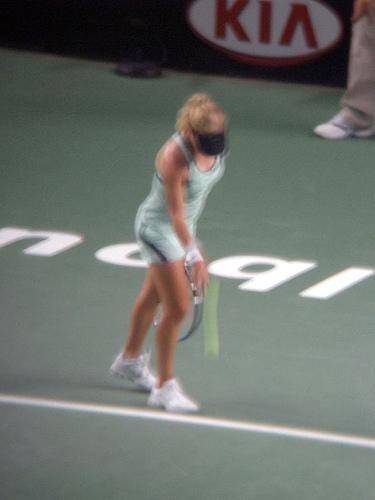What is the woman holding?
Give a very brief answer. Tennis racket. What is the woman doing?
Answer briefly. Playing tennis. What game is the girl playing?
Quick response, please. Tennis. What car company is advertising at the match?
Keep it brief. Kia. 